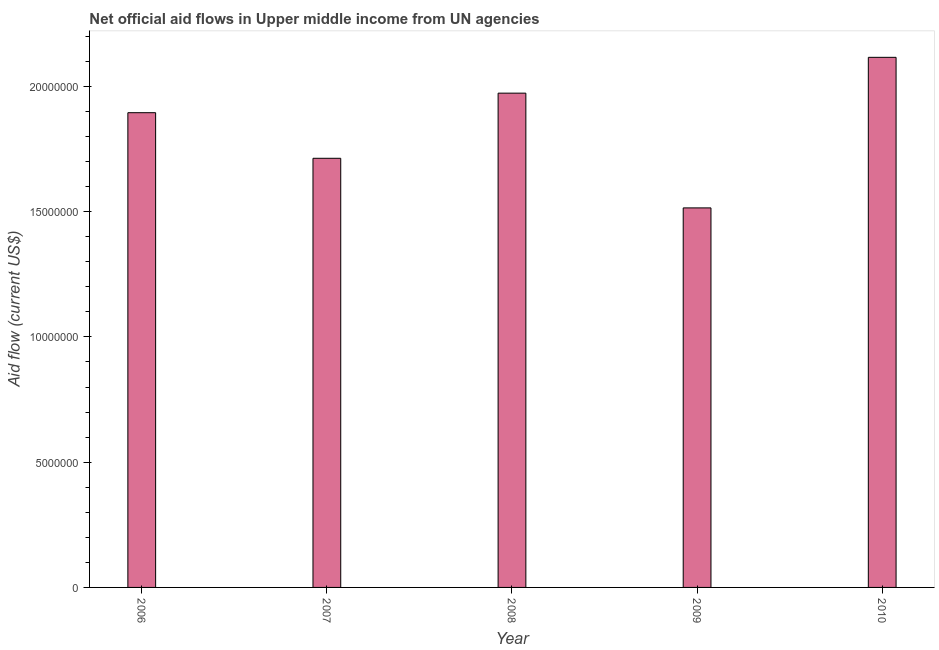Does the graph contain any zero values?
Give a very brief answer. No. Does the graph contain grids?
Provide a succinct answer. No. What is the title of the graph?
Offer a very short reply. Net official aid flows in Upper middle income from UN agencies. What is the label or title of the X-axis?
Your response must be concise. Year. What is the label or title of the Y-axis?
Offer a terse response. Aid flow (current US$). What is the net official flows from un agencies in 2010?
Your answer should be very brief. 2.12e+07. Across all years, what is the maximum net official flows from un agencies?
Make the answer very short. 2.12e+07. Across all years, what is the minimum net official flows from un agencies?
Make the answer very short. 1.52e+07. In which year was the net official flows from un agencies minimum?
Provide a short and direct response. 2009. What is the sum of the net official flows from un agencies?
Your response must be concise. 9.21e+07. What is the difference between the net official flows from un agencies in 2007 and 2008?
Give a very brief answer. -2.60e+06. What is the average net official flows from un agencies per year?
Offer a terse response. 1.84e+07. What is the median net official flows from un agencies?
Provide a succinct answer. 1.90e+07. In how many years, is the net official flows from un agencies greater than 15000000 US$?
Keep it short and to the point. 5. Do a majority of the years between 2008 and 2010 (inclusive) have net official flows from un agencies greater than 4000000 US$?
Your answer should be compact. Yes. What is the ratio of the net official flows from un agencies in 2008 to that in 2010?
Your response must be concise. 0.93. Is the difference between the net official flows from un agencies in 2006 and 2007 greater than the difference between any two years?
Offer a very short reply. No. What is the difference between the highest and the second highest net official flows from un agencies?
Ensure brevity in your answer.  1.43e+06. Is the sum of the net official flows from un agencies in 2007 and 2010 greater than the maximum net official flows from un agencies across all years?
Your response must be concise. Yes. What is the difference between the highest and the lowest net official flows from un agencies?
Your response must be concise. 6.01e+06. How many years are there in the graph?
Ensure brevity in your answer.  5. What is the difference between two consecutive major ticks on the Y-axis?
Your answer should be compact. 5.00e+06. What is the Aid flow (current US$) in 2006?
Provide a succinct answer. 1.90e+07. What is the Aid flow (current US$) of 2007?
Your answer should be compact. 1.71e+07. What is the Aid flow (current US$) of 2008?
Offer a very short reply. 1.97e+07. What is the Aid flow (current US$) in 2009?
Provide a short and direct response. 1.52e+07. What is the Aid flow (current US$) in 2010?
Keep it short and to the point. 2.12e+07. What is the difference between the Aid flow (current US$) in 2006 and 2007?
Offer a very short reply. 1.82e+06. What is the difference between the Aid flow (current US$) in 2006 and 2008?
Offer a terse response. -7.80e+05. What is the difference between the Aid flow (current US$) in 2006 and 2009?
Make the answer very short. 3.80e+06. What is the difference between the Aid flow (current US$) in 2006 and 2010?
Offer a very short reply. -2.21e+06. What is the difference between the Aid flow (current US$) in 2007 and 2008?
Provide a short and direct response. -2.60e+06. What is the difference between the Aid flow (current US$) in 2007 and 2009?
Make the answer very short. 1.98e+06. What is the difference between the Aid flow (current US$) in 2007 and 2010?
Your response must be concise. -4.03e+06. What is the difference between the Aid flow (current US$) in 2008 and 2009?
Your answer should be compact. 4.58e+06. What is the difference between the Aid flow (current US$) in 2008 and 2010?
Give a very brief answer. -1.43e+06. What is the difference between the Aid flow (current US$) in 2009 and 2010?
Your answer should be compact. -6.01e+06. What is the ratio of the Aid flow (current US$) in 2006 to that in 2007?
Offer a very short reply. 1.11. What is the ratio of the Aid flow (current US$) in 2006 to that in 2008?
Your answer should be very brief. 0.96. What is the ratio of the Aid flow (current US$) in 2006 to that in 2009?
Give a very brief answer. 1.25. What is the ratio of the Aid flow (current US$) in 2006 to that in 2010?
Make the answer very short. 0.9. What is the ratio of the Aid flow (current US$) in 2007 to that in 2008?
Give a very brief answer. 0.87. What is the ratio of the Aid flow (current US$) in 2007 to that in 2009?
Provide a succinct answer. 1.13. What is the ratio of the Aid flow (current US$) in 2007 to that in 2010?
Offer a terse response. 0.81. What is the ratio of the Aid flow (current US$) in 2008 to that in 2009?
Your answer should be compact. 1.3. What is the ratio of the Aid flow (current US$) in 2008 to that in 2010?
Keep it short and to the point. 0.93. What is the ratio of the Aid flow (current US$) in 2009 to that in 2010?
Provide a short and direct response. 0.72. 